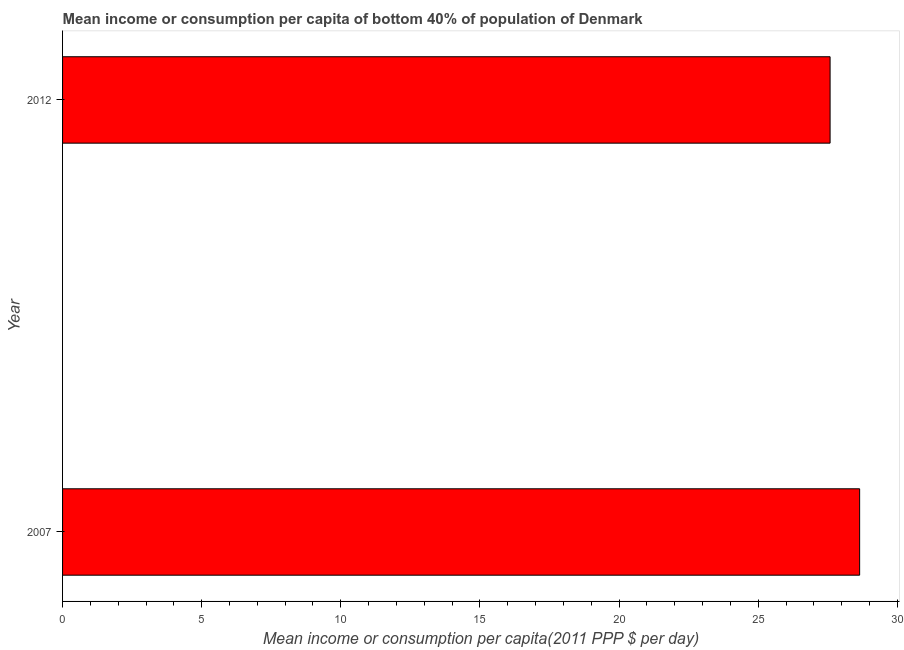Does the graph contain any zero values?
Your response must be concise. No. Does the graph contain grids?
Make the answer very short. No. What is the title of the graph?
Give a very brief answer. Mean income or consumption per capita of bottom 40% of population of Denmark. What is the label or title of the X-axis?
Provide a short and direct response. Mean income or consumption per capita(2011 PPP $ per day). What is the mean income or consumption in 2007?
Your answer should be very brief. 28.65. Across all years, what is the maximum mean income or consumption?
Provide a succinct answer. 28.65. Across all years, what is the minimum mean income or consumption?
Offer a terse response. 27.58. What is the sum of the mean income or consumption?
Provide a short and direct response. 56.23. What is the difference between the mean income or consumption in 2007 and 2012?
Make the answer very short. 1.06. What is the average mean income or consumption per year?
Provide a succinct answer. 28.11. What is the median mean income or consumption?
Give a very brief answer. 28.11. What is the ratio of the mean income or consumption in 2007 to that in 2012?
Make the answer very short. 1.04. Are all the bars in the graph horizontal?
Provide a short and direct response. Yes. What is the difference between two consecutive major ticks on the X-axis?
Your answer should be compact. 5. What is the Mean income or consumption per capita(2011 PPP $ per day) of 2007?
Your answer should be very brief. 28.65. What is the Mean income or consumption per capita(2011 PPP $ per day) of 2012?
Make the answer very short. 27.58. What is the difference between the Mean income or consumption per capita(2011 PPP $ per day) in 2007 and 2012?
Keep it short and to the point. 1.06. What is the ratio of the Mean income or consumption per capita(2011 PPP $ per day) in 2007 to that in 2012?
Keep it short and to the point. 1.04. 